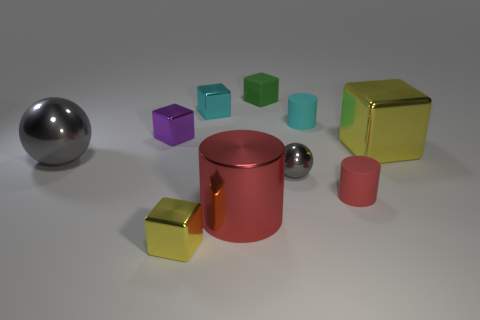What is the material of the small green thing?
Your response must be concise. Rubber. There is a tiny cylinder behind the gray thing that is on the left side of the tiny purple shiny thing on the left side of the tiny gray object; what is it made of?
Your response must be concise. Rubber. Does the green matte thing have the same size as the yellow metallic block right of the large red shiny object?
Make the answer very short. No. What number of things are shiny balls on the right side of the small yellow metal thing or blocks that are in front of the big metal sphere?
Offer a terse response. 2. There is a metal ball that is on the left side of the green block; what is its color?
Provide a short and direct response. Gray. There is a gray metallic ball to the right of the large gray metallic object; is there a yellow metal thing in front of it?
Your response must be concise. Yes. Are there fewer gray shiny things than large objects?
Your answer should be very brief. Yes. What material is the cube left of the tiny cube that is in front of the big yellow block made of?
Your response must be concise. Metal. Do the cyan rubber object and the green object have the same size?
Your answer should be very brief. Yes. What number of things are either green matte spheres or small shiny objects?
Provide a succinct answer. 4. 